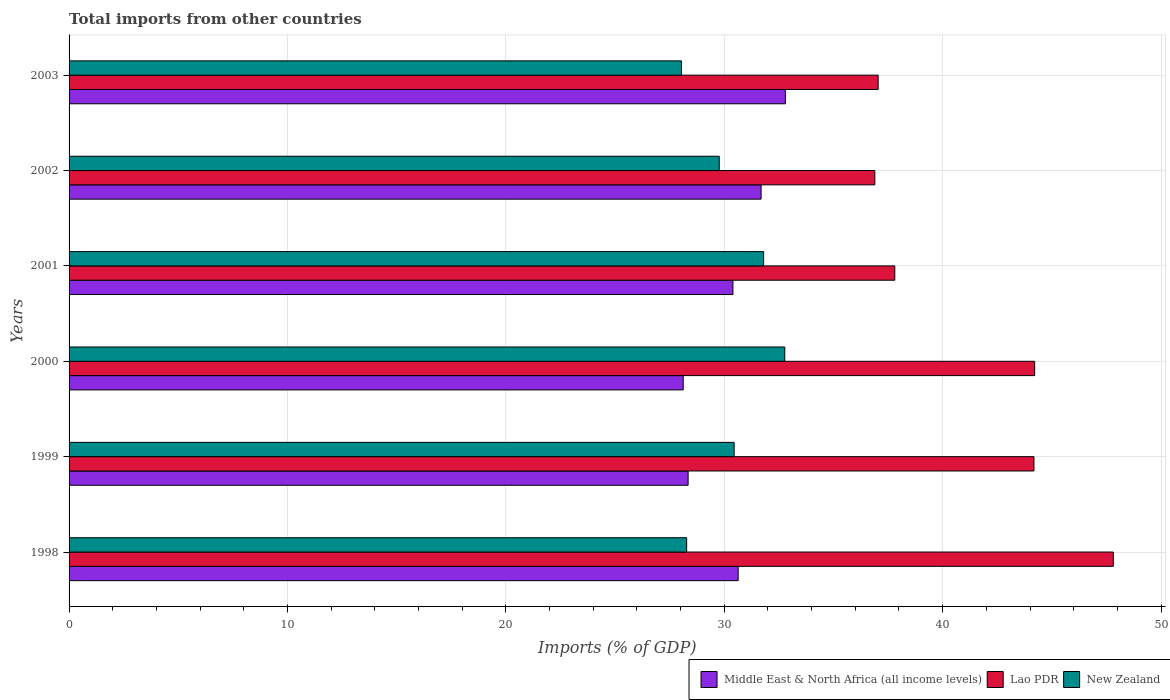How many different coloured bars are there?
Make the answer very short. 3. Are the number of bars on each tick of the Y-axis equal?
Keep it short and to the point. Yes. How many bars are there on the 2nd tick from the top?
Your response must be concise. 3. What is the total imports in Lao PDR in 2001?
Provide a succinct answer. 37.81. Across all years, what is the maximum total imports in New Zealand?
Give a very brief answer. 32.77. Across all years, what is the minimum total imports in Lao PDR?
Make the answer very short. 36.89. In which year was the total imports in Lao PDR maximum?
Ensure brevity in your answer.  1998. In which year was the total imports in New Zealand minimum?
Ensure brevity in your answer.  2003. What is the total total imports in New Zealand in the graph?
Keep it short and to the point. 181.12. What is the difference between the total imports in New Zealand in 1998 and that in 2003?
Your answer should be very brief. 0.24. What is the difference between the total imports in Middle East & North Africa (all income levels) in 1999 and the total imports in Lao PDR in 2003?
Make the answer very short. -8.7. What is the average total imports in New Zealand per year?
Give a very brief answer. 30.19. In the year 1998, what is the difference between the total imports in Lao PDR and total imports in New Zealand?
Make the answer very short. 19.54. In how many years, is the total imports in Middle East & North Africa (all income levels) greater than 48 %?
Your answer should be very brief. 0. What is the ratio of the total imports in Lao PDR in 1998 to that in 1999?
Make the answer very short. 1.08. What is the difference between the highest and the second highest total imports in Lao PDR?
Provide a short and direct response. 3.6. What is the difference between the highest and the lowest total imports in Lao PDR?
Keep it short and to the point. 10.92. What does the 2nd bar from the top in 1998 represents?
Provide a short and direct response. Lao PDR. What does the 3rd bar from the bottom in 2003 represents?
Keep it short and to the point. New Zealand. How many bars are there?
Your answer should be compact. 18. How many years are there in the graph?
Give a very brief answer. 6. Does the graph contain grids?
Provide a succinct answer. Yes. Where does the legend appear in the graph?
Offer a very short reply. Bottom right. What is the title of the graph?
Make the answer very short. Total imports from other countries. What is the label or title of the X-axis?
Ensure brevity in your answer.  Imports (% of GDP). What is the label or title of the Y-axis?
Give a very brief answer. Years. What is the Imports (% of GDP) in Middle East & North Africa (all income levels) in 1998?
Give a very brief answer. 30.64. What is the Imports (% of GDP) in Lao PDR in 1998?
Make the answer very short. 47.81. What is the Imports (% of GDP) in New Zealand in 1998?
Your response must be concise. 28.28. What is the Imports (% of GDP) in Middle East & North Africa (all income levels) in 1999?
Ensure brevity in your answer.  28.35. What is the Imports (% of GDP) in Lao PDR in 1999?
Provide a short and direct response. 44.18. What is the Imports (% of GDP) of New Zealand in 1999?
Ensure brevity in your answer.  30.45. What is the Imports (% of GDP) in Middle East & North Africa (all income levels) in 2000?
Provide a succinct answer. 28.12. What is the Imports (% of GDP) in Lao PDR in 2000?
Provide a succinct answer. 44.21. What is the Imports (% of GDP) in New Zealand in 2000?
Provide a succinct answer. 32.77. What is the Imports (% of GDP) of Middle East & North Africa (all income levels) in 2001?
Give a very brief answer. 30.4. What is the Imports (% of GDP) in Lao PDR in 2001?
Offer a terse response. 37.81. What is the Imports (% of GDP) of New Zealand in 2001?
Offer a terse response. 31.8. What is the Imports (% of GDP) of Middle East & North Africa (all income levels) in 2002?
Your response must be concise. 31.69. What is the Imports (% of GDP) of Lao PDR in 2002?
Your answer should be compact. 36.89. What is the Imports (% of GDP) in New Zealand in 2002?
Ensure brevity in your answer.  29.77. What is the Imports (% of GDP) of Middle East & North Africa (all income levels) in 2003?
Provide a short and direct response. 32.8. What is the Imports (% of GDP) of Lao PDR in 2003?
Keep it short and to the point. 37.05. What is the Imports (% of GDP) of New Zealand in 2003?
Give a very brief answer. 28.04. Across all years, what is the maximum Imports (% of GDP) of Middle East & North Africa (all income levels)?
Offer a terse response. 32.8. Across all years, what is the maximum Imports (% of GDP) of Lao PDR?
Offer a very short reply. 47.81. Across all years, what is the maximum Imports (% of GDP) in New Zealand?
Your response must be concise. 32.77. Across all years, what is the minimum Imports (% of GDP) in Middle East & North Africa (all income levels)?
Provide a succinct answer. 28.12. Across all years, what is the minimum Imports (% of GDP) of Lao PDR?
Keep it short and to the point. 36.89. Across all years, what is the minimum Imports (% of GDP) of New Zealand?
Offer a very short reply. 28.04. What is the total Imports (% of GDP) of Middle East & North Africa (all income levels) in the graph?
Make the answer very short. 181.99. What is the total Imports (% of GDP) of Lao PDR in the graph?
Provide a succinct answer. 247.96. What is the total Imports (% of GDP) of New Zealand in the graph?
Provide a short and direct response. 181.12. What is the difference between the Imports (% of GDP) of Middle East & North Africa (all income levels) in 1998 and that in 1999?
Your answer should be very brief. 2.29. What is the difference between the Imports (% of GDP) in Lao PDR in 1998 and that in 1999?
Keep it short and to the point. 3.63. What is the difference between the Imports (% of GDP) in New Zealand in 1998 and that in 1999?
Give a very brief answer. -2.18. What is the difference between the Imports (% of GDP) in Middle East & North Africa (all income levels) in 1998 and that in 2000?
Offer a very short reply. 2.52. What is the difference between the Imports (% of GDP) in Lao PDR in 1998 and that in 2000?
Offer a terse response. 3.6. What is the difference between the Imports (% of GDP) in New Zealand in 1998 and that in 2000?
Offer a terse response. -4.49. What is the difference between the Imports (% of GDP) in Middle East & North Africa (all income levels) in 1998 and that in 2001?
Provide a short and direct response. 0.24. What is the difference between the Imports (% of GDP) in Lao PDR in 1998 and that in 2001?
Give a very brief answer. 10. What is the difference between the Imports (% of GDP) of New Zealand in 1998 and that in 2001?
Provide a short and direct response. -3.52. What is the difference between the Imports (% of GDP) of Middle East & North Africa (all income levels) in 1998 and that in 2002?
Provide a short and direct response. -1.05. What is the difference between the Imports (% of GDP) in Lao PDR in 1998 and that in 2002?
Your answer should be very brief. 10.92. What is the difference between the Imports (% of GDP) in New Zealand in 1998 and that in 2002?
Keep it short and to the point. -1.49. What is the difference between the Imports (% of GDP) in Middle East & North Africa (all income levels) in 1998 and that in 2003?
Keep it short and to the point. -2.16. What is the difference between the Imports (% of GDP) in Lao PDR in 1998 and that in 2003?
Your answer should be compact. 10.77. What is the difference between the Imports (% of GDP) in New Zealand in 1998 and that in 2003?
Your answer should be very brief. 0.24. What is the difference between the Imports (% of GDP) in Middle East & North Africa (all income levels) in 1999 and that in 2000?
Offer a very short reply. 0.23. What is the difference between the Imports (% of GDP) in Lao PDR in 1999 and that in 2000?
Provide a short and direct response. -0.03. What is the difference between the Imports (% of GDP) of New Zealand in 1999 and that in 2000?
Your response must be concise. -2.32. What is the difference between the Imports (% of GDP) of Middle East & North Africa (all income levels) in 1999 and that in 2001?
Keep it short and to the point. -2.05. What is the difference between the Imports (% of GDP) in Lao PDR in 1999 and that in 2001?
Your response must be concise. 6.37. What is the difference between the Imports (% of GDP) in New Zealand in 1999 and that in 2001?
Make the answer very short. -1.35. What is the difference between the Imports (% of GDP) of Middle East & North Africa (all income levels) in 1999 and that in 2002?
Offer a terse response. -3.34. What is the difference between the Imports (% of GDP) of Lao PDR in 1999 and that in 2002?
Your response must be concise. 7.29. What is the difference between the Imports (% of GDP) of New Zealand in 1999 and that in 2002?
Your answer should be compact. 0.68. What is the difference between the Imports (% of GDP) in Middle East & North Africa (all income levels) in 1999 and that in 2003?
Keep it short and to the point. -4.45. What is the difference between the Imports (% of GDP) of Lao PDR in 1999 and that in 2003?
Provide a succinct answer. 7.14. What is the difference between the Imports (% of GDP) in New Zealand in 1999 and that in 2003?
Make the answer very short. 2.41. What is the difference between the Imports (% of GDP) of Middle East & North Africa (all income levels) in 2000 and that in 2001?
Your answer should be compact. -2.28. What is the difference between the Imports (% of GDP) in Lao PDR in 2000 and that in 2001?
Your answer should be compact. 6.4. What is the difference between the Imports (% of GDP) in New Zealand in 2000 and that in 2001?
Your answer should be compact. 0.97. What is the difference between the Imports (% of GDP) of Middle East & North Africa (all income levels) in 2000 and that in 2002?
Offer a very short reply. -3.57. What is the difference between the Imports (% of GDP) in Lao PDR in 2000 and that in 2002?
Ensure brevity in your answer.  7.32. What is the difference between the Imports (% of GDP) of New Zealand in 2000 and that in 2002?
Make the answer very short. 3. What is the difference between the Imports (% of GDP) of Middle East & North Africa (all income levels) in 2000 and that in 2003?
Give a very brief answer. -4.68. What is the difference between the Imports (% of GDP) of Lao PDR in 2000 and that in 2003?
Give a very brief answer. 7.17. What is the difference between the Imports (% of GDP) of New Zealand in 2000 and that in 2003?
Offer a very short reply. 4.73. What is the difference between the Imports (% of GDP) of Middle East & North Africa (all income levels) in 2001 and that in 2002?
Your answer should be compact. -1.29. What is the difference between the Imports (% of GDP) of Lao PDR in 2001 and that in 2002?
Your answer should be compact. 0.92. What is the difference between the Imports (% of GDP) of New Zealand in 2001 and that in 2002?
Make the answer very short. 2.03. What is the difference between the Imports (% of GDP) of Middle East & North Africa (all income levels) in 2001 and that in 2003?
Offer a very short reply. -2.4. What is the difference between the Imports (% of GDP) in Lao PDR in 2001 and that in 2003?
Your response must be concise. 0.76. What is the difference between the Imports (% of GDP) in New Zealand in 2001 and that in 2003?
Make the answer very short. 3.76. What is the difference between the Imports (% of GDP) of Middle East & North Africa (all income levels) in 2002 and that in 2003?
Ensure brevity in your answer.  -1.11. What is the difference between the Imports (% of GDP) in Lao PDR in 2002 and that in 2003?
Your response must be concise. -0.15. What is the difference between the Imports (% of GDP) of New Zealand in 2002 and that in 2003?
Give a very brief answer. 1.73. What is the difference between the Imports (% of GDP) in Middle East & North Africa (all income levels) in 1998 and the Imports (% of GDP) in Lao PDR in 1999?
Your answer should be very brief. -13.55. What is the difference between the Imports (% of GDP) in Middle East & North Africa (all income levels) in 1998 and the Imports (% of GDP) in New Zealand in 1999?
Keep it short and to the point. 0.18. What is the difference between the Imports (% of GDP) in Lao PDR in 1998 and the Imports (% of GDP) in New Zealand in 1999?
Ensure brevity in your answer.  17.36. What is the difference between the Imports (% of GDP) in Middle East & North Africa (all income levels) in 1998 and the Imports (% of GDP) in Lao PDR in 2000?
Ensure brevity in your answer.  -13.58. What is the difference between the Imports (% of GDP) in Middle East & North Africa (all income levels) in 1998 and the Imports (% of GDP) in New Zealand in 2000?
Keep it short and to the point. -2.13. What is the difference between the Imports (% of GDP) in Lao PDR in 1998 and the Imports (% of GDP) in New Zealand in 2000?
Your answer should be very brief. 15.04. What is the difference between the Imports (% of GDP) of Middle East & North Africa (all income levels) in 1998 and the Imports (% of GDP) of Lao PDR in 2001?
Your response must be concise. -7.17. What is the difference between the Imports (% of GDP) in Middle East & North Africa (all income levels) in 1998 and the Imports (% of GDP) in New Zealand in 2001?
Ensure brevity in your answer.  -1.17. What is the difference between the Imports (% of GDP) in Lao PDR in 1998 and the Imports (% of GDP) in New Zealand in 2001?
Make the answer very short. 16.01. What is the difference between the Imports (% of GDP) of Middle East & North Africa (all income levels) in 1998 and the Imports (% of GDP) of Lao PDR in 2002?
Your answer should be compact. -6.26. What is the difference between the Imports (% of GDP) in Middle East & North Africa (all income levels) in 1998 and the Imports (% of GDP) in New Zealand in 2002?
Offer a terse response. 0.87. What is the difference between the Imports (% of GDP) of Lao PDR in 1998 and the Imports (% of GDP) of New Zealand in 2002?
Your answer should be compact. 18.04. What is the difference between the Imports (% of GDP) in Middle East & North Africa (all income levels) in 1998 and the Imports (% of GDP) in Lao PDR in 2003?
Your answer should be compact. -6.41. What is the difference between the Imports (% of GDP) of Middle East & North Africa (all income levels) in 1998 and the Imports (% of GDP) of New Zealand in 2003?
Your answer should be compact. 2.6. What is the difference between the Imports (% of GDP) in Lao PDR in 1998 and the Imports (% of GDP) in New Zealand in 2003?
Your answer should be compact. 19.77. What is the difference between the Imports (% of GDP) in Middle East & North Africa (all income levels) in 1999 and the Imports (% of GDP) in Lao PDR in 2000?
Offer a terse response. -15.87. What is the difference between the Imports (% of GDP) of Middle East & North Africa (all income levels) in 1999 and the Imports (% of GDP) of New Zealand in 2000?
Offer a very short reply. -4.43. What is the difference between the Imports (% of GDP) of Lao PDR in 1999 and the Imports (% of GDP) of New Zealand in 2000?
Your response must be concise. 11.41. What is the difference between the Imports (% of GDP) of Middle East & North Africa (all income levels) in 1999 and the Imports (% of GDP) of Lao PDR in 2001?
Your response must be concise. -9.46. What is the difference between the Imports (% of GDP) in Middle East & North Africa (all income levels) in 1999 and the Imports (% of GDP) in New Zealand in 2001?
Ensure brevity in your answer.  -3.46. What is the difference between the Imports (% of GDP) in Lao PDR in 1999 and the Imports (% of GDP) in New Zealand in 2001?
Provide a short and direct response. 12.38. What is the difference between the Imports (% of GDP) of Middle East & North Africa (all income levels) in 1999 and the Imports (% of GDP) of Lao PDR in 2002?
Your response must be concise. -8.55. What is the difference between the Imports (% of GDP) in Middle East & North Africa (all income levels) in 1999 and the Imports (% of GDP) in New Zealand in 2002?
Provide a succinct answer. -1.43. What is the difference between the Imports (% of GDP) in Lao PDR in 1999 and the Imports (% of GDP) in New Zealand in 2002?
Your response must be concise. 14.41. What is the difference between the Imports (% of GDP) in Middle East & North Africa (all income levels) in 1999 and the Imports (% of GDP) in Lao PDR in 2003?
Keep it short and to the point. -8.7. What is the difference between the Imports (% of GDP) in Middle East & North Africa (all income levels) in 1999 and the Imports (% of GDP) in New Zealand in 2003?
Offer a very short reply. 0.31. What is the difference between the Imports (% of GDP) in Lao PDR in 1999 and the Imports (% of GDP) in New Zealand in 2003?
Give a very brief answer. 16.14. What is the difference between the Imports (% of GDP) of Middle East & North Africa (all income levels) in 2000 and the Imports (% of GDP) of Lao PDR in 2001?
Keep it short and to the point. -9.69. What is the difference between the Imports (% of GDP) in Middle East & North Africa (all income levels) in 2000 and the Imports (% of GDP) in New Zealand in 2001?
Provide a succinct answer. -3.68. What is the difference between the Imports (% of GDP) of Lao PDR in 2000 and the Imports (% of GDP) of New Zealand in 2001?
Offer a very short reply. 12.41. What is the difference between the Imports (% of GDP) of Middle East & North Africa (all income levels) in 2000 and the Imports (% of GDP) of Lao PDR in 2002?
Provide a short and direct response. -8.77. What is the difference between the Imports (% of GDP) in Middle East & North Africa (all income levels) in 2000 and the Imports (% of GDP) in New Zealand in 2002?
Provide a short and direct response. -1.65. What is the difference between the Imports (% of GDP) of Lao PDR in 2000 and the Imports (% of GDP) of New Zealand in 2002?
Provide a succinct answer. 14.44. What is the difference between the Imports (% of GDP) in Middle East & North Africa (all income levels) in 2000 and the Imports (% of GDP) in Lao PDR in 2003?
Your answer should be very brief. -8.93. What is the difference between the Imports (% of GDP) of Middle East & North Africa (all income levels) in 2000 and the Imports (% of GDP) of New Zealand in 2003?
Ensure brevity in your answer.  0.08. What is the difference between the Imports (% of GDP) in Lao PDR in 2000 and the Imports (% of GDP) in New Zealand in 2003?
Provide a succinct answer. 16.17. What is the difference between the Imports (% of GDP) of Middle East & North Africa (all income levels) in 2001 and the Imports (% of GDP) of Lao PDR in 2002?
Provide a succinct answer. -6.5. What is the difference between the Imports (% of GDP) in Middle East & North Africa (all income levels) in 2001 and the Imports (% of GDP) in New Zealand in 2002?
Ensure brevity in your answer.  0.63. What is the difference between the Imports (% of GDP) in Lao PDR in 2001 and the Imports (% of GDP) in New Zealand in 2002?
Make the answer very short. 8.04. What is the difference between the Imports (% of GDP) of Middle East & North Africa (all income levels) in 2001 and the Imports (% of GDP) of Lao PDR in 2003?
Offer a very short reply. -6.65. What is the difference between the Imports (% of GDP) of Middle East & North Africa (all income levels) in 2001 and the Imports (% of GDP) of New Zealand in 2003?
Keep it short and to the point. 2.36. What is the difference between the Imports (% of GDP) in Lao PDR in 2001 and the Imports (% of GDP) in New Zealand in 2003?
Offer a very short reply. 9.77. What is the difference between the Imports (% of GDP) of Middle East & North Africa (all income levels) in 2002 and the Imports (% of GDP) of Lao PDR in 2003?
Provide a short and direct response. -5.36. What is the difference between the Imports (% of GDP) in Middle East & North Africa (all income levels) in 2002 and the Imports (% of GDP) in New Zealand in 2003?
Your response must be concise. 3.65. What is the difference between the Imports (% of GDP) of Lao PDR in 2002 and the Imports (% of GDP) of New Zealand in 2003?
Your answer should be very brief. 8.85. What is the average Imports (% of GDP) of Middle East & North Africa (all income levels) per year?
Keep it short and to the point. 30.33. What is the average Imports (% of GDP) of Lao PDR per year?
Give a very brief answer. 41.33. What is the average Imports (% of GDP) in New Zealand per year?
Your response must be concise. 30.19. In the year 1998, what is the difference between the Imports (% of GDP) in Middle East & North Africa (all income levels) and Imports (% of GDP) in Lao PDR?
Provide a succinct answer. -17.18. In the year 1998, what is the difference between the Imports (% of GDP) in Middle East & North Africa (all income levels) and Imports (% of GDP) in New Zealand?
Provide a short and direct response. 2.36. In the year 1998, what is the difference between the Imports (% of GDP) of Lao PDR and Imports (% of GDP) of New Zealand?
Your response must be concise. 19.54. In the year 1999, what is the difference between the Imports (% of GDP) in Middle East & North Africa (all income levels) and Imports (% of GDP) in Lao PDR?
Offer a terse response. -15.84. In the year 1999, what is the difference between the Imports (% of GDP) in Middle East & North Africa (all income levels) and Imports (% of GDP) in New Zealand?
Give a very brief answer. -2.11. In the year 1999, what is the difference between the Imports (% of GDP) in Lao PDR and Imports (% of GDP) in New Zealand?
Your answer should be very brief. 13.73. In the year 2000, what is the difference between the Imports (% of GDP) of Middle East & North Africa (all income levels) and Imports (% of GDP) of Lao PDR?
Provide a succinct answer. -16.09. In the year 2000, what is the difference between the Imports (% of GDP) in Middle East & North Africa (all income levels) and Imports (% of GDP) in New Zealand?
Your response must be concise. -4.65. In the year 2000, what is the difference between the Imports (% of GDP) of Lao PDR and Imports (% of GDP) of New Zealand?
Your response must be concise. 11.44. In the year 2001, what is the difference between the Imports (% of GDP) in Middle East & North Africa (all income levels) and Imports (% of GDP) in Lao PDR?
Your answer should be very brief. -7.41. In the year 2001, what is the difference between the Imports (% of GDP) in Middle East & North Africa (all income levels) and Imports (% of GDP) in New Zealand?
Make the answer very short. -1.41. In the year 2001, what is the difference between the Imports (% of GDP) of Lao PDR and Imports (% of GDP) of New Zealand?
Provide a short and direct response. 6.01. In the year 2002, what is the difference between the Imports (% of GDP) of Middle East & North Africa (all income levels) and Imports (% of GDP) of Lao PDR?
Give a very brief answer. -5.21. In the year 2002, what is the difference between the Imports (% of GDP) in Middle East & North Africa (all income levels) and Imports (% of GDP) in New Zealand?
Your answer should be very brief. 1.92. In the year 2002, what is the difference between the Imports (% of GDP) of Lao PDR and Imports (% of GDP) of New Zealand?
Your response must be concise. 7.12. In the year 2003, what is the difference between the Imports (% of GDP) of Middle East & North Africa (all income levels) and Imports (% of GDP) of Lao PDR?
Your answer should be very brief. -4.25. In the year 2003, what is the difference between the Imports (% of GDP) in Middle East & North Africa (all income levels) and Imports (% of GDP) in New Zealand?
Give a very brief answer. 4.76. In the year 2003, what is the difference between the Imports (% of GDP) in Lao PDR and Imports (% of GDP) in New Zealand?
Your answer should be very brief. 9.01. What is the ratio of the Imports (% of GDP) of Middle East & North Africa (all income levels) in 1998 to that in 1999?
Your answer should be compact. 1.08. What is the ratio of the Imports (% of GDP) in Lao PDR in 1998 to that in 1999?
Ensure brevity in your answer.  1.08. What is the ratio of the Imports (% of GDP) in Middle East & North Africa (all income levels) in 1998 to that in 2000?
Offer a terse response. 1.09. What is the ratio of the Imports (% of GDP) in Lao PDR in 1998 to that in 2000?
Ensure brevity in your answer.  1.08. What is the ratio of the Imports (% of GDP) of New Zealand in 1998 to that in 2000?
Keep it short and to the point. 0.86. What is the ratio of the Imports (% of GDP) in Middle East & North Africa (all income levels) in 1998 to that in 2001?
Keep it short and to the point. 1.01. What is the ratio of the Imports (% of GDP) in Lao PDR in 1998 to that in 2001?
Your answer should be very brief. 1.26. What is the ratio of the Imports (% of GDP) of New Zealand in 1998 to that in 2001?
Your response must be concise. 0.89. What is the ratio of the Imports (% of GDP) in Middle East & North Africa (all income levels) in 1998 to that in 2002?
Your response must be concise. 0.97. What is the ratio of the Imports (% of GDP) of Lao PDR in 1998 to that in 2002?
Provide a succinct answer. 1.3. What is the ratio of the Imports (% of GDP) of New Zealand in 1998 to that in 2002?
Your answer should be compact. 0.95. What is the ratio of the Imports (% of GDP) of Middle East & North Africa (all income levels) in 1998 to that in 2003?
Ensure brevity in your answer.  0.93. What is the ratio of the Imports (% of GDP) of Lao PDR in 1998 to that in 2003?
Offer a terse response. 1.29. What is the ratio of the Imports (% of GDP) in New Zealand in 1998 to that in 2003?
Your answer should be compact. 1.01. What is the ratio of the Imports (% of GDP) in New Zealand in 1999 to that in 2000?
Give a very brief answer. 0.93. What is the ratio of the Imports (% of GDP) of Middle East & North Africa (all income levels) in 1999 to that in 2001?
Offer a terse response. 0.93. What is the ratio of the Imports (% of GDP) of Lao PDR in 1999 to that in 2001?
Provide a short and direct response. 1.17. What is the ratio of the Imports (% of GDP) of New Zealand in 1999 to that in 2001?
Give a very brief answer. 0.96. What is the ratio of the Imports (% of GDP) of Middle East & North Africa (all income levels) in 1999 to that in 2002?
Ensure brevity in your answer.  0.89. What is the ratio of the Imports (% of GDP) in Lao PDR in 1999 to that in 2002?
Ensure brevity in your answer.  1.2. What is the ratio of the Imports (% of GDP) of New Zealand in 1999 to that in 2002?
Offer a very short reply. 1.02. What is the ratio of the Imports (% of GDP) in Middle East & North Africa (all income levels) in 1999 to that in 2003?
Make the answer very short. 0.86. What is the ratio of the Imports (% of GDP) of Lao PDR in 1999 to that in 2003?
Give a very brief answer. 1.19. What is the ratio of the Imports (% of GDP) of New Zealand in 1999 to that in 2003?
Offer a terse response. 1.09. What is the ratio of the Imports (% of GDP) of Middle East & North Africa (all income levels) in 2000 to that in 2001?
Offer a very short reply. 0.93. What is the ratio of the Imports (% of GDP) in Lao PDR in 2000 to that in 2001?
Your answer should be very brief. 1.17. What is the ratio of the Imports (% of GDP) of New Zealand in 2000 to that in 2001?
Your answer should be compact. 1.03. What is the ratio of the Imports (% of GDP) of Middle East & North Africa (all income levels) in 2000 to that in 2002?
Provide a succinct answer. 0.89. What is the ratio of the Imports (% of GDP) of Lao PDR in 2000 to that in 2002?
Give a very brief answer. 1.2. What is the ratio of the Imports (% of GDP) in New Zealand in 2000 to that in 2002?
Give a very brief answer. 1.1. What is the ratio of the Imports (% of GDP) in Middle East & North Africa (all income levels) in 2000 to that in 2003?
Your answer should be very brief. 0.86. What is the ratio of the Imports (% of GDP) of Lao PDR in 2000 to that in 2003?
Provide a succinct answer. 1.19. What is the ratio of the Imports (% of GDP) in New Zealand in 2000 to that in 2003?
Offer a terse response. 1.17. What is the ratio of the Imports (% of GDP) of Middle East & North Africa (all income levels) in 2001 to that in 2002?
Offer a very short reply. 0.96. What is the ratio of the Imports (% of GDP) in Lao PDR in 2001 to that in 2002?
Your response must be concise. 1.02. What is the ratio of the Imports (% of GDP) in New Zealand in 2001 to that in 2002?
Provide a short and direct response. 1.07. What is the ratio of the Imports (% of GDP) in Middle East & North Africa (all income levels) in 2001 to that in 2003?
Keep it short and to the point. 0.93. What is the ratio of the Imports (% of GDP) in Lao PDR in 2001 to that in 2003?
Your response must be concise. 1.02. What is the ratio of the Imports (% of GDP) in New Zealand in 2001 to that in 2003?
Provide a short and direct response. 1.13. What is the ratio of the Imports (% of GDP) in Middle East & North Africa (all income levels) in 2002 to that in 2003?
Keep it short and to the point. 0.97. What is the ratio of the Imports (% of GDP) of Lao PDR in 2002 to that in 2003?
Give a very brief answer. 1. What is the ratio of the Imports (% of GDP) in New Zealand in 2002 to that in 2003?
Make the answer very short. 1.06. What is the difference between the highest and the second highest Imports (% of GDP) in Middle East & North Africa (all income levels)?
Keep it short and to the point. 1.11. What is the difference between the highest and the second highest Imports (% of GDP) of Lao PDR?
Make the answer very short. 3.6. What is the difference between the highest and the second highest Imports (% of GDP) in New Zealand?
Give a very brief answer. 0.97. What is the difference between the highest and the lowest Imports (% of GDP) of Middle East & North Africa (all income levels)?
Offer a terse response. 4.68. What is the difference between the highest and the lowest Imports (% of GDP) of Lao PDR?
Give a very brief answer. 10.92. What is the difference between the highest and the lowest Imports (% of GDP) in New Zealand?
Ensure brevity in your answer.  4.73. 